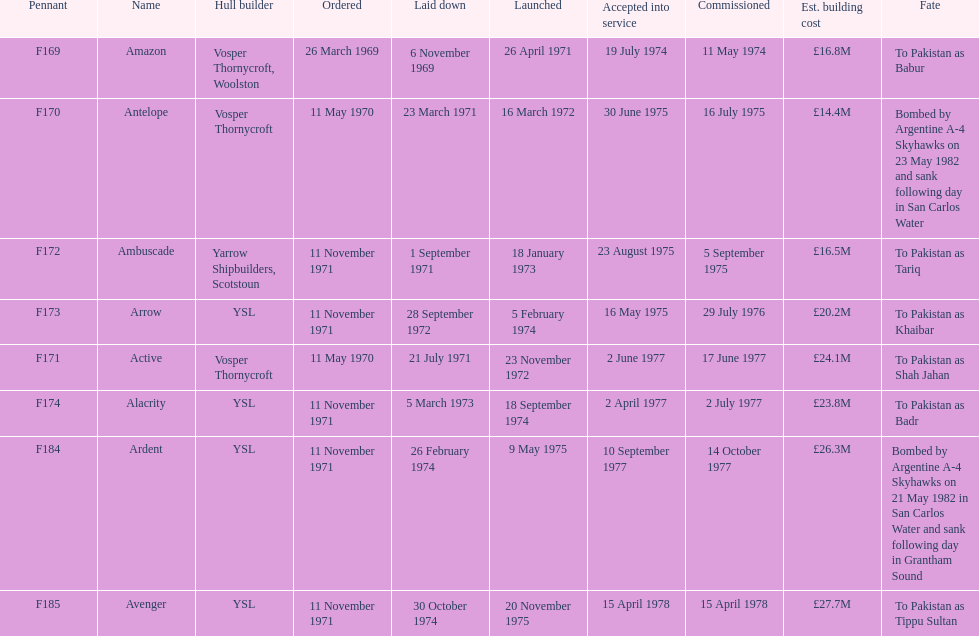What is the last listed pennant? F185. 